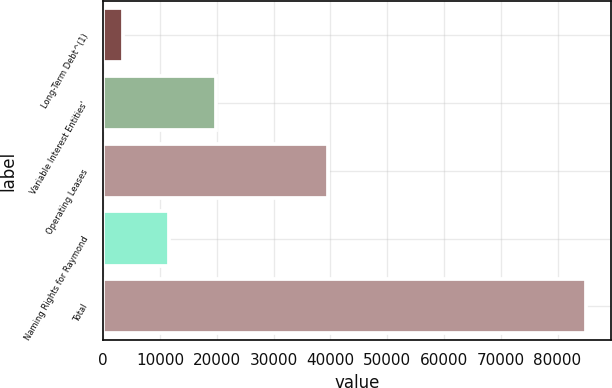<chart> <loc_0><loc_0><loc_500><loc_500><bar_chart><fcel>Long-Term Debt^(1)<fcel>Variable Interest Entities'<fcel>Operating Leases<fcel>Naming Rights for Raymond<fcel>Total<nl><fcel>3445<fcel>19774.8<fcel>39532<fcel>11609.9<fcel>85094<nl></chart> 